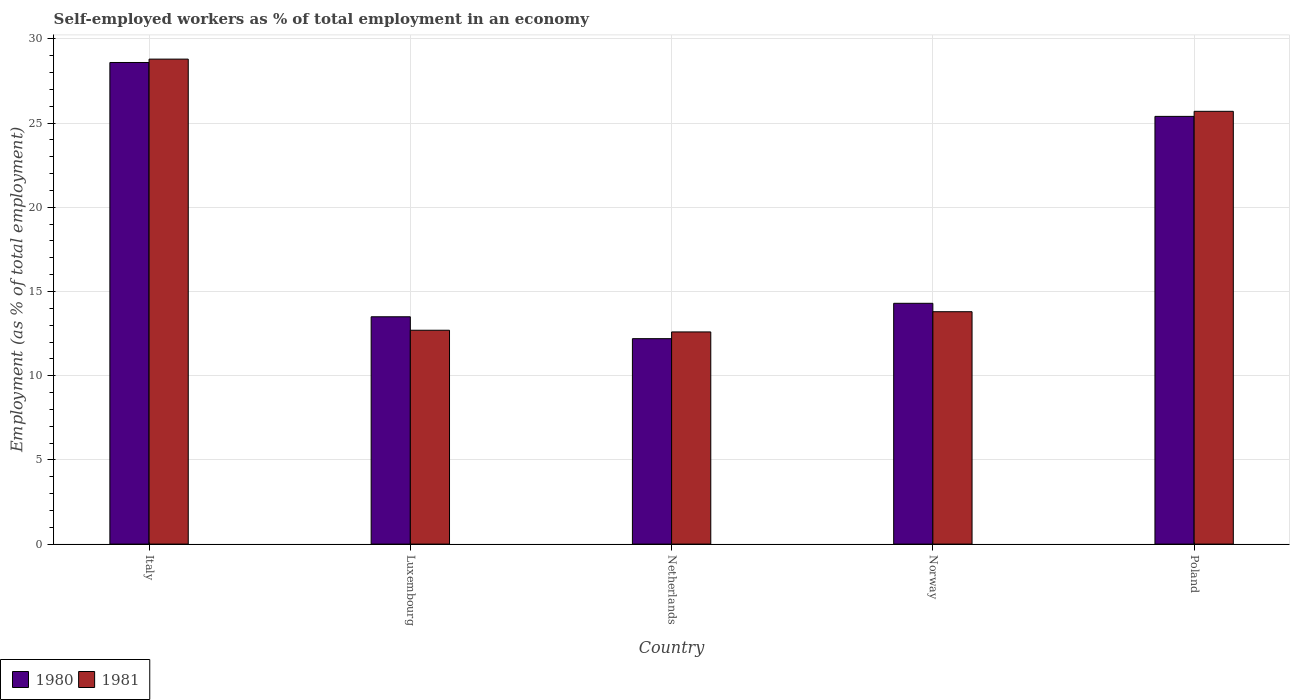How many different coloured bars are there?
Give a very brief answer. 2. Are the number of bars per tick equal to the number of legend labels?
Keep it short and to the point. Yes. How many bars are there on the 2nd tick from the right?
Provide a short and direct response. 2. What is the label of the 4th group of bars from the left?
Give a very brief answer. Norway. What is the percentage of self-employed workers in 1980 in Italy?
Provide a short and direct response. 28.6. Across all countries, what is the maximum percentage of self-employed workers in 1981?
Provide a succinct answer. 28.8. Across all countries, what is the minimum percentage of self-employed workers in 1980?
Your answer should be compact. 12.2. What is the total percentage of self-employed workers in 1981 in the graph?
Provide a short and direct response. 93.6. What is the difference between the percentage of self-employed workers in 1980 in Netherlands and that in Norway?
Your answer should be compact. -2.1. What is the difference between the percentage of self-employed workers in 1981 in Luxembourg and the percentage of self-employed workers in 1980 in Norway?
Offer a terse response. -1.6. What is the average percentage of self-employed workers in 1981 per country?
Your response must be concise. 18.72. What is the difference between the percentage of self-employed workers of/in 1980 and percentage of self-employed workers of/in 1981 in Luxembourg?
Make the answer very short. 0.8. What is the ratio of the percentage of self-employed workers in 1981 in Netherlands to that in Norway?
Your response must be concise. 0.91. Is the difference between the percentage of self-employed workers in 1980 in Italy and Norway greater than the difference between the percentage of self-employed workers in 1981 in Italy and Norway?
Your response must be concise. No. What is the difference between the highest and the second highest percentage of self-employed workers in 1980?
Your answer should be compact. -3.2. What is the difference between the highest and the lowest percentage of self-employed workers in 1981?
Your response must be concise. 16.2. In how many countries, is the percentage of self-employed workers in 1980 greater than the average percentage of self-employed workers in 1980 taken over all countries?
Give a very brief answer. 2. Is the sum of the percentage of self-employed workers in 1981 in Norway and Poland greater than the maximum percentage of self-employed workers in 1980 across all countries?
Keep it short and to the point. Yes. What does the 1st bar from the right in Norway represents?
Keep it short and to the point. 1981. What is the difference between two consecutive major ticks on the Y-axis?
Give a very brief answer. 5. Does the graph contain grids?
Your answer should be compact. Yes. How many legend labels are there?
Provide a succinct answer. 2. What is the title of the graph?
Your response must be concise. Self-employed workers as % of total employment in an economy. Does "1990" appear as one of the legend labels in the graph?
Make the answer very short. No. What is the label or title of the Y-axis?
Your answer should be compact. Employment (as % of total employment). What is the Employment (as % of total employment) of 1980 in Italy?
Your answer should be very brief. 28.6. What is the Employment (as % of total employment) in 1981 in Italy?
Offer a terse response. 28.8. What is the Employment (as % of total employment) of 1980 in Luxembourg?
Provide a succinct answer. 13.5. What is the Employment (as % of total employment) in 1981 in Luxembourg?
Offer a terse response. 12.7. What is the Employment (as % of total employment) in 1980 in Netherlands?
Offer a terse response. 12.2. What is the Employment (as % of total employment) in 1981 in Netherlands?
Your answer should be compact. 12.6. What is the Employment (as % of total employment) in 1980 in Norway?
Offer a very short reply. 14.3. What is the Employment (as % of total employment) in 1981 in Norway?
Keep it short and to the point. 13.8. What is the Employment (as % of total employment) in 1980 in Poland?
Ensure brevity in your answer.  25.4. What is the Employment (as % of total employment) in 1981 in Poland?
Your answer should be compact. 25.7. Across all countries, what is the maximum Employment (as % of total employment) of 1980?
Ensure brevity in your answer.  28.6. Across all countries, what is the maximum Employment (as % of total employment) in 1981?
Give a very brief answer. 28.8. Across all countries, what is the minimum Employment (as % of total employment) of 1980?
Keep it short and to the point. 12.2. Across all countries, what is the minimum Employment (as % of total employment) of 1981?
Your answer should be compact. 12.6. What is the total Employment (as % of total employment) of 1980 in the graph?
Your response must be concise. 94. What is the total Employment (as % of total employment) of 1981 in the graph?
Your answer should be very brief. 93.6. What is the difference between the Employment (as % of total employment) in 1980 in Italy and that in Luxembourg?
Your response must be concise. 15.1. What is the difference between the Employment (as % of total employment) of 1980 in Italy and that in Netherlands?
Provide a short and direct response. 16.4. What is the difference between the Employment (as % of total employment) in 1981 in Italy and that in Norway?
Offer a very short reply. 15. What is the difference between the Employment (as % of total employment) in 1980 in Italy and that in Poland?
Your answer should be very brief. 3.2. What is the difference between the Employment (as % of total employment) of 1981 in Italy and that in Poland?
Your answer should be very brief. 3.1. What is the difference between the Employment (as % of total employment) of 1981 in Luxembourg and that in Norway?
Offer a terse response. -1.1. What is the difference between the Employment (as % of total employment) of 1981 in Luxembourg and that in Poland?
Ensure brevity in your answer.  -13. What is the difference between the Employment (as % of total employment) of 1980 in Netherlands and that in Norway?
Your response must be concise. -2.1. What is the difference between the Employment (as % of total employment) of 1981 in Netherlands and that in Norway?
Provide a succinct answer. -1.2. What is the difference between the Employment (as % of total employment) in 1980 in Norway and that in Poland?
Provide a short and direct response. -11.1. What is the difference between the Employment (as % of total employment) in 1980 in Italy and the Employment (as % of total employment) in 1981 in Luxembourg?
Keep it short and to the point. 15.9. What is the difference between the Employment (as % of total employment) in 1980 in Italy and the Employment (as % of total employment) in 1981 in Netherlands?
Provide a succinct answer. 16. What is the difference between the Employment (as % of total employment) in 1980 in Italy and the Employment (as % of total employment) in 1981 in Norway?
Provide a succinct answer. 14.8. What is the difference between the Employment (as % of total employment) of 1980 in Luxembourg and the Employment (as % of total employment) of 1981 in Norway?
Your answer should be compact. -0.3. What is the difference between the Employment (as % of total employment) in 1980 in Netherlands and the Employment (as % of total employment) in 1981 in Poland?
Your answer should be very brief. -13.5. What is the difference between the Employment (as % of total employment) in 1980 in Norway and the Employment (as % of total employment) in 1981 in Poland?
Ensure brevity in your answer.  -11.4. What is the average Employment (as % of total employment) in 1981 per country?
Provide a short and direct response. 18.72. What is the difference between the Employment (as % of total employment) of 1980 and Employment (as % of total employment) of 1981 in Luxembourg?
Your response must be concise. 0.8. What is the difference between the Employment (as % of total employment) of 1980 and Employment (as % of total employment) of 1981 in Norway?
Make the answer very short. 0.5. What is the ratio of the Employment (as % of total employment) in 1980 in Italy to that in Luxembourg?
Your answer should be compact. 2.12. What is the ratio of the Employment (as % of total employment) of 1981 in Italy to that in Luxembourg?
Your answer should be very brief. 2.27. What is the ratio of the Employment (as % of total employment) in 1980 in Italy to that in Netherlands?
Your answer should be very brief. 2.34. What is the ratio of the Employment (as % of total employment) of 1981 in Italy to that in Netherlands?
Your answer should be compact. 2.29. What is the ratio of the Employment (as % of total employment) in 1980 in Italy to that in Norway?
Make the answer very short. 2. What is the ratio of the Employment (as % of total employment) of 1981 in Italy to that in Norway?
Ensure brevity in your answer.  2.09. What is the ratio of the Employment (as % of total employment) in 1980 in Italy to that in Poland?
Your answer should be very brief. 1.13. What is the ratio of the Employment (as % of total employment) of 1981 in Italy to that in Poland?
Offer a terse response. 1.12. What is the ratio of the Employment (as % of total employment) of 1980 in Luxembourg to that in Netherlands?
Offer a terse response. 1.11. What is the ratio of the Employment (as % of total employment) of 1981 in Luxembourg to that in Netherlands?
Your response must be concise. 1.01. What is the ratio of the Employment (as % of total employment) in 1980 in Luxembourg to that in Norway?
Provide a succinct answer. 0.94. What is the ratio of the Employment (as % of total employment) in 1981 in Luxembourg to that in Norway?
Provide a short and direct response. 0.92. What is the ratio of the Employment (as % of total employment) in 1980 in Luxembourg to that in Poland?
Provide a succinct answer. 0.53. What is the ratio of the Employment (as % of total employment) of 1981 in Luxembourg to that in Poland?
Your response must be concise. 0.49. What is the ratio of the Employment (as % of total employment) of 1980 in Netherlands to that in Norway?
Make the answer very short. 0.85. What is the ratio of the Employment (as % of total employment) in 1981 in Netherlands to that in Norway?
Your answer should be compact. 0.91. What is the ratio of the Employment (as % of total employment) of 1980 in Netherlands to that in Poland?
Offer a very short reply. 0.48. What is the ratio of the Employment (as % of total employment) in 1981 in Netherlands to that in Poland?
Ensure brevity in your answer.  0.49. What is the ratio of the Employment (as % of total employment) of 1980 in Norway to that in Poland?
Offer a very short reply. 0.56. What is the ratio of the Employment (as % of total employment) of 1981 in Norway to that in Poland?
Give a very brief answer. 0.54. What is the difference between the highest and the second highest Employment (as % of total employment) in 1981?
Ensure brevity in your answer.  3.1. 